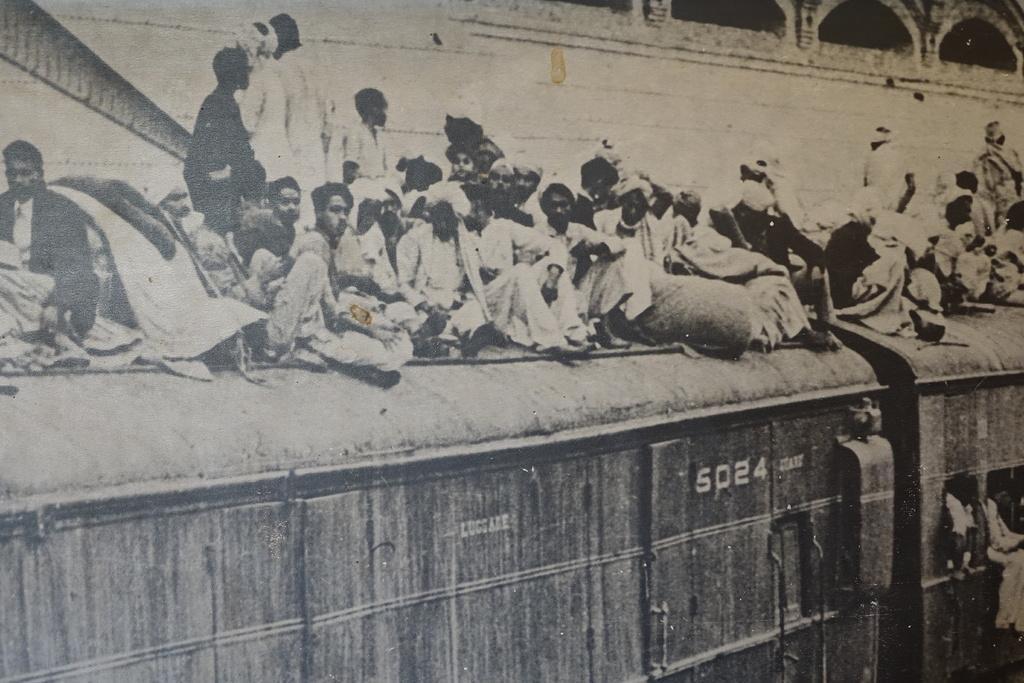Describe this image in one or two sentences. In the image we can see there is a train and there are people sitting on the train. Behind there is a building and its written ¨5024¨ on the train. The image is in black and white colour. 